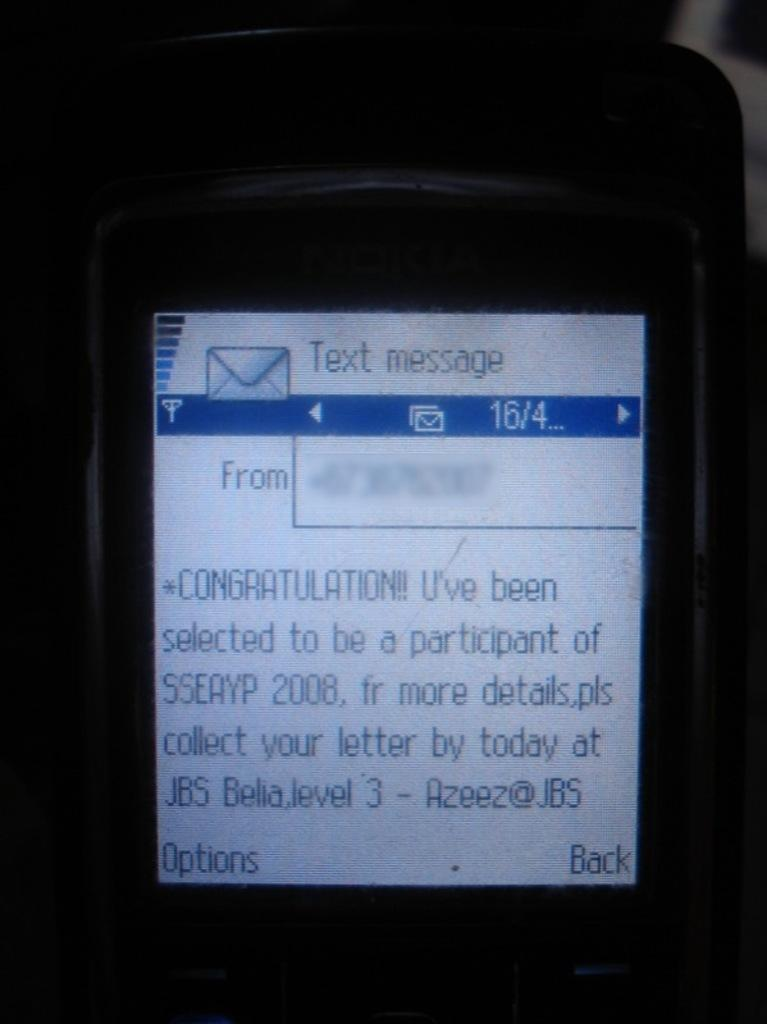Provide a one-sentence caption for the provided image. A zoomed in cellphone with the text on the screen talking about participation in a contest. 